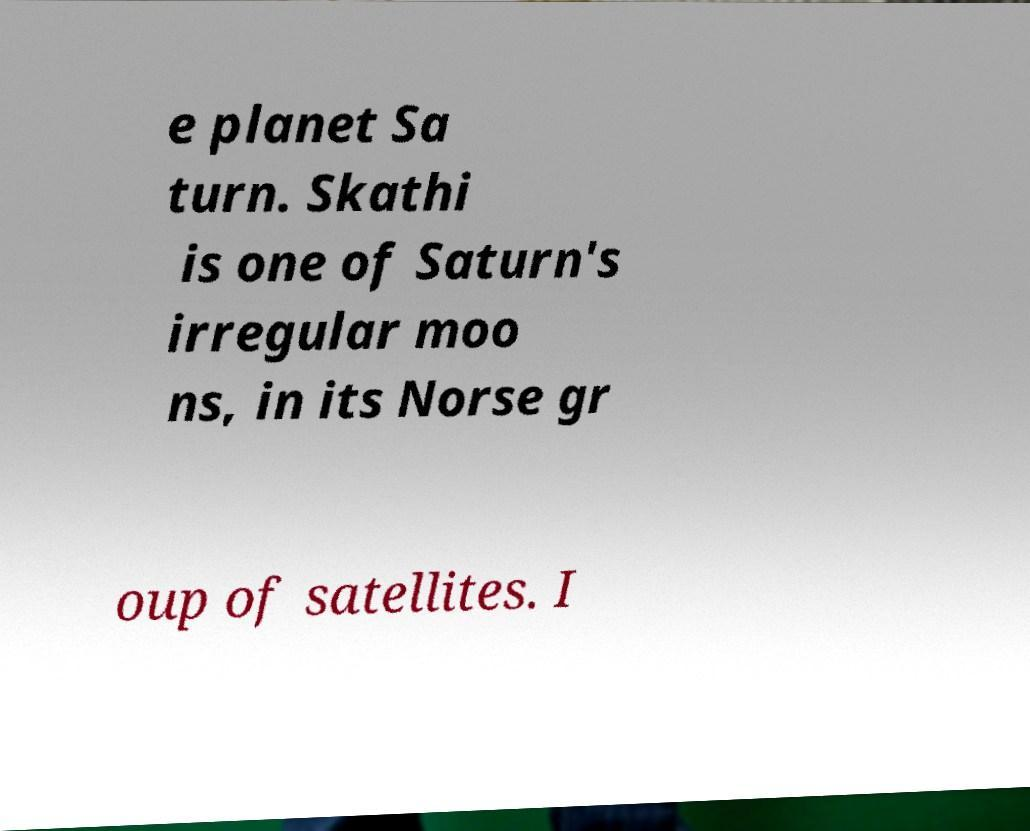For documentation purposes, I need the text within this image transcribed. Could you provide that? e planet Sa turn. Skathi is one of Saturn's irregular moo ns, in its Norse gr oup of satellites. I 